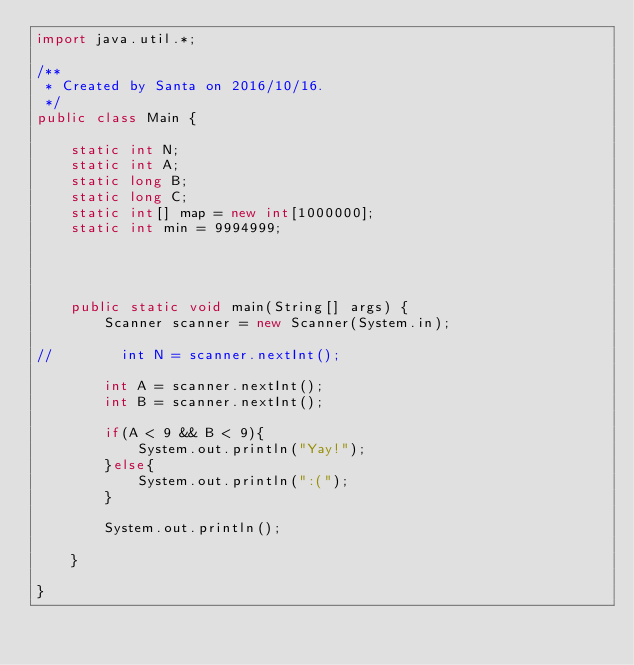Convert code to text. <code><loc_0><loc_0><loc_500><loc_500><_Java_>import java.util.*;

/**
 * Created by Santa on 2016/10/16.
 */
public class Main {

    static int N;
    static int A;
    static long B;
    static long C;
    static int[] map = new int[1000000];
    static int min = 9994999;




    public static void main(String[] args) {
        Scanner scanner = new Scanner(System.in);

//        int N = scanner.nextInt();

        int A = scanner.nextInt();
        int B = scanner.nextInt();

        if(A < 9 && B < 9){
            System.out.println("Yay!");
        }else{
            System.out.println(":(");
        }

        System.out.println();

    }

}

</code> 